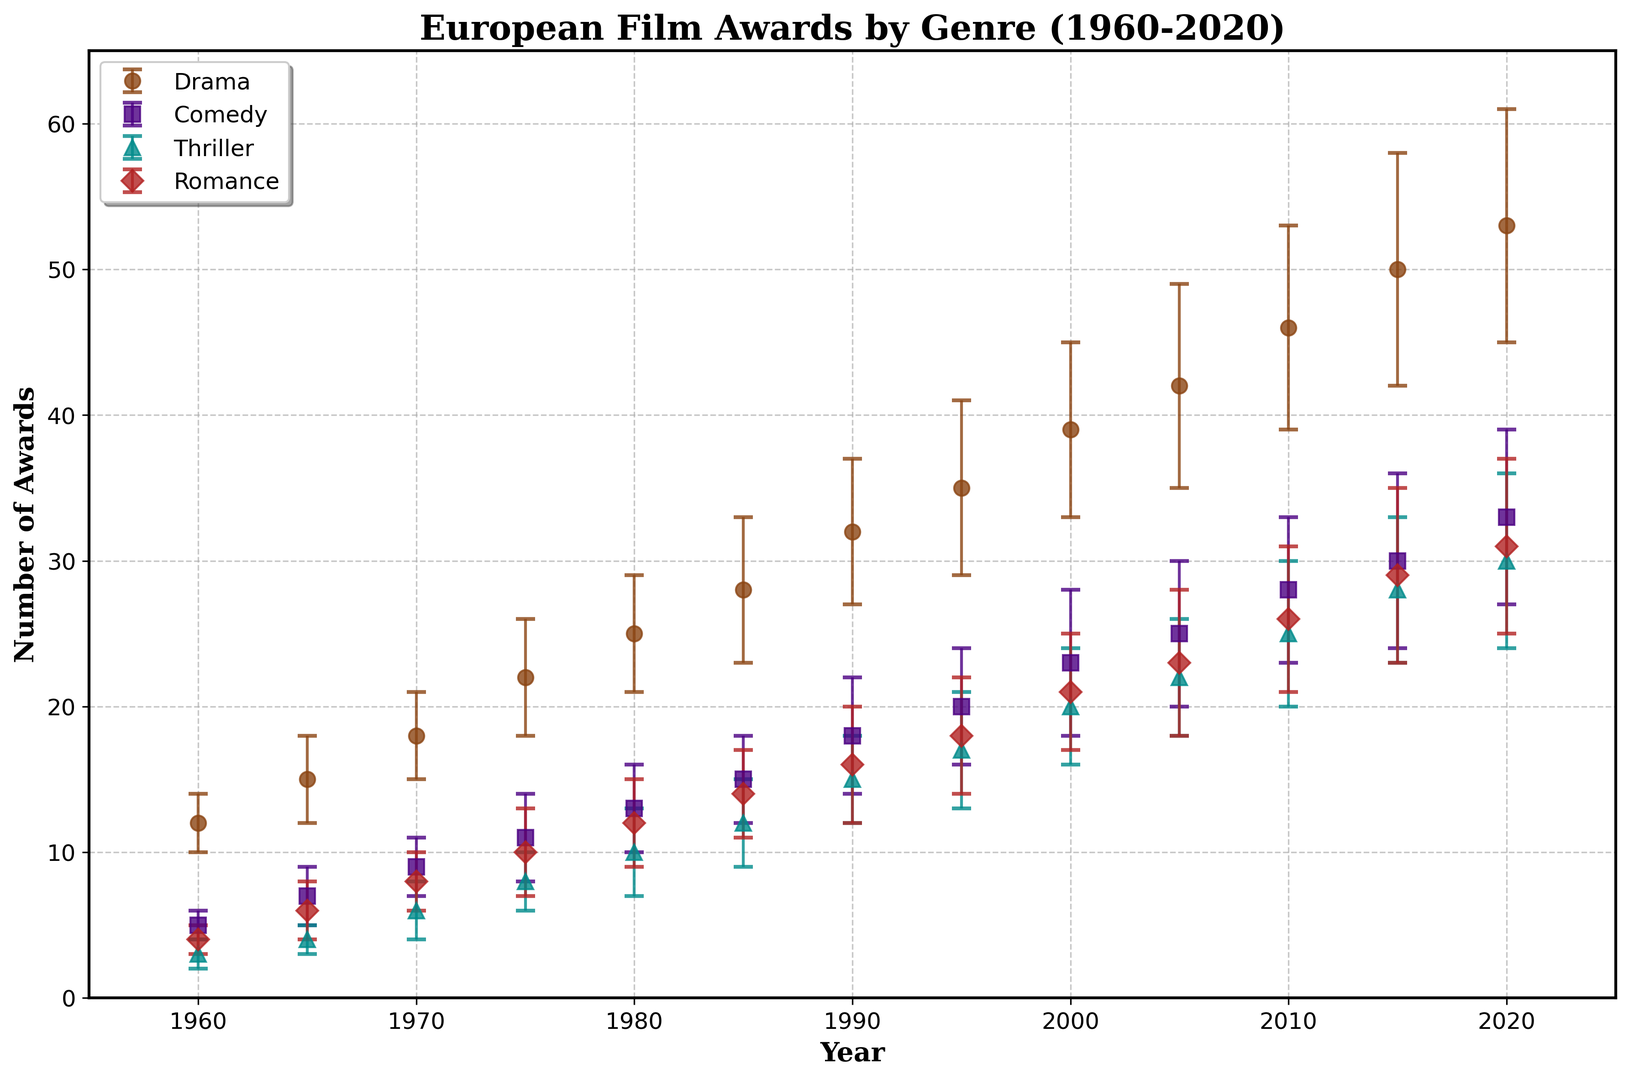What's the genre with the most awards won in 1985? In 1985, the bars show Drama with 28 awards, Comedy with 15 awards, Thriller with 12 awards, and Romance with 14 awards. Drama has the highest value.
Answer: Drama How many more awards did Comedy win in 2010 compared to 1980? Comedy won 28 awards in 2010 and 13 awards in 1980. The difference is 28 - 13 = 15.
Answer: 15 Which year shows the greatest increase in awards for Thriller compared to the previous year? Comparing each interval, the largest increase for Thriller is between 1980 and 1985, from 10 to 12 awards, an increase of 2 awards.
Answer: 1985 What is the average number of awards won by Romance in the 1970s? In 1970, Romance won 8 awards. In 1975, Romance won 10 awards. The average is (8 + 10) / 2 = 9.
Answer: 9 How did the Drama genre trend overall from 1960 to 2020? Drama steadily increased from 12 awards in 1960 to 53 awards in 2020, indicating a consistent upward trend.
Answer: Upward Which two genres had the closest number of awards in 2000? In 2000, Comedy had 23 awards and Romance had 21 awards, with a difference of only 2 awards.
Answer: Comedy and Romance Was the number of awards for Thriller ever higher than Comedy? No, in every year shown, Comedy consistently had more awards than Thriller.
Answer: No By how much did the number of awards for Drama increase from 1975 to 2020? Drama had 22 awards in 1975 and increased to 53 awards in 2020. The increase is 53 - 22 = 31.
Answer: 31 Did Romance ever surpass Drama in any year? No, Drama consistently had more awards than Romance in all years presented.
Answer: No 